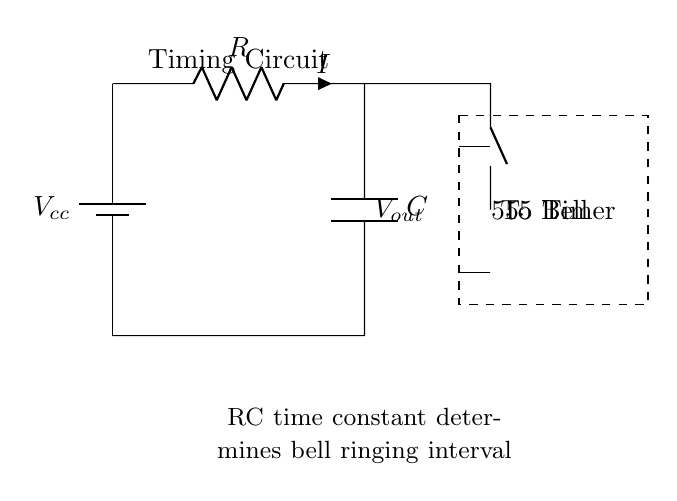What type of components are used in this circuit? The circuit uses a resistor and a capacitor as its main components, shown as the labels R and C.
Answer: Resistor and Capacitor What does the 555 Timer do in this circuit? The 555 Timer is used to control the timing intervals for the bell ringing, effectively regulating when the bell is activated based on the RC time constant.
Answer: Control timing What is the function of the resistor in this circuit? The resistor limits the current flow through the circuit and is part of determining the time constant for the bell ringing interval.
Answer: Limit current What happens when the capacitor is charged? When the capacitor is charged, it stores electrical energy and eventually discharges, which activates the bell at set intervals.
Answer: Activates bell How does the RC time constant affect the timing? The RC time constant (calculated as the product of resistance and capacitance) determines the duration of time the capacitor takes to charge and discharge, directly correlating with ringing intervals.
Answer: Determines duration What component connects the output to the bell? The connection from the circuit's output to the bell is made via the normally open switch, which allows current to flow when the circuit is activated.
Answer: Normally open switch What is represented by the dashed rectangle in the circuit? The dashed rectangle represents the 555 Timer IC, indicating where this specific timing control component is located within the circuit.
Answer: 555 Timer IC 